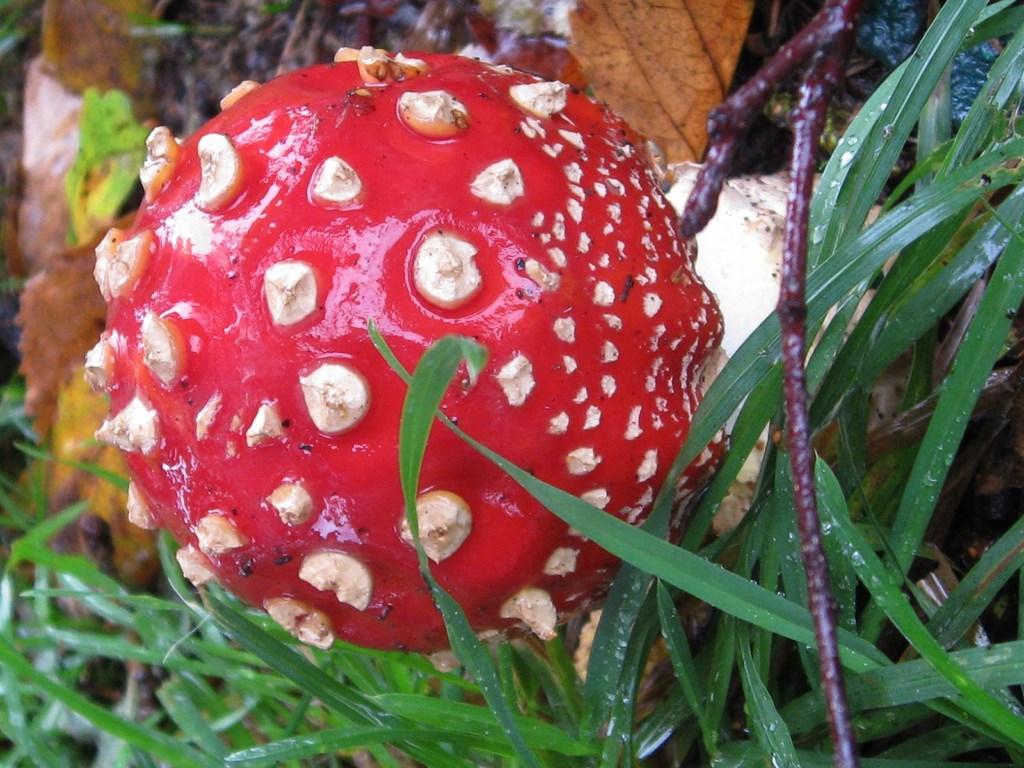Please provide a concise description of this image. In this image we can see a red color fruit and grass. 